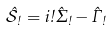Convert formula to latex. <formula><loc_0><loc_0><loc_500><loc_500>\hat { \mathcal { S } } _ { \omega } = i \omega \hat { \Sigma } _ { \omega } - \hat { \Gamma } _ { \omega }</formula> 